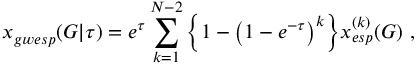Convert formula to latex. <formula><loc_0><loc_0><loc_500><loc_500>x _ { g w e s p } ( G | \tau ) = e ^ { \tau } \sum _ { k = 1 } ^ { N - 2 } \left \{ 1 - \left ( 1 - e ^ { - \tau } \right ) ^ { k } \right \} x _ { e s p } ^ { ( k ) } ( G ) \ ,</formula> 